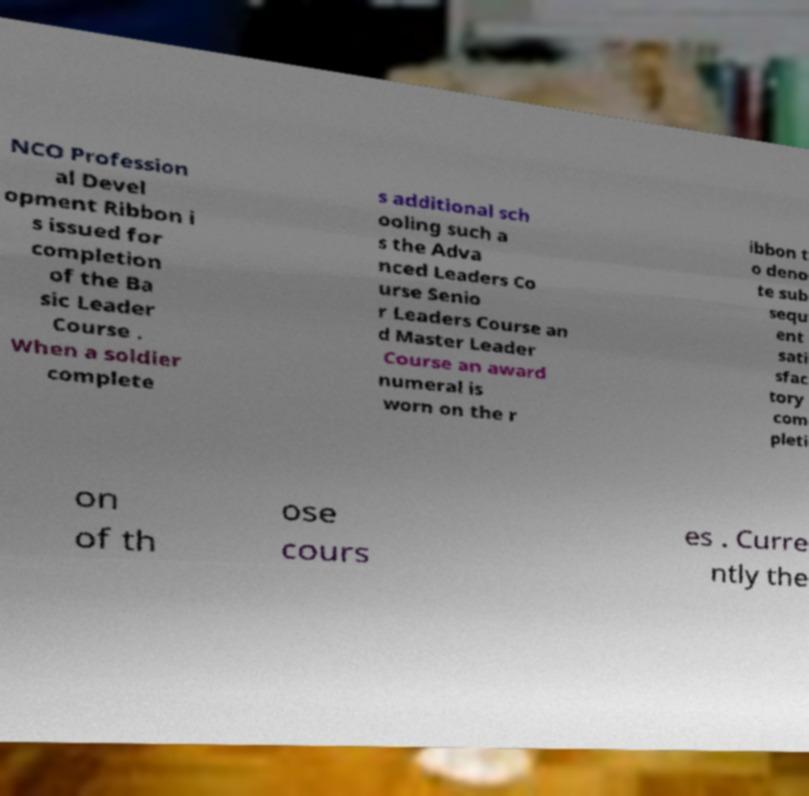What messages or text are displayed in this image? I need them in a readable, typed format. NCO Profession al Devel opment Ribbon i s issued for completion of the Ba sic Leader Course . When a soldier complete s additional sch ooling such a s the Adva nced Leaders Co urse Senio r Leaders Course an d Master Leader Course an award numeral is worn on the r ibbon t o deno te sub sequ ent sati sfac tory com pleti on of th ose cours es . Curre ntly the 